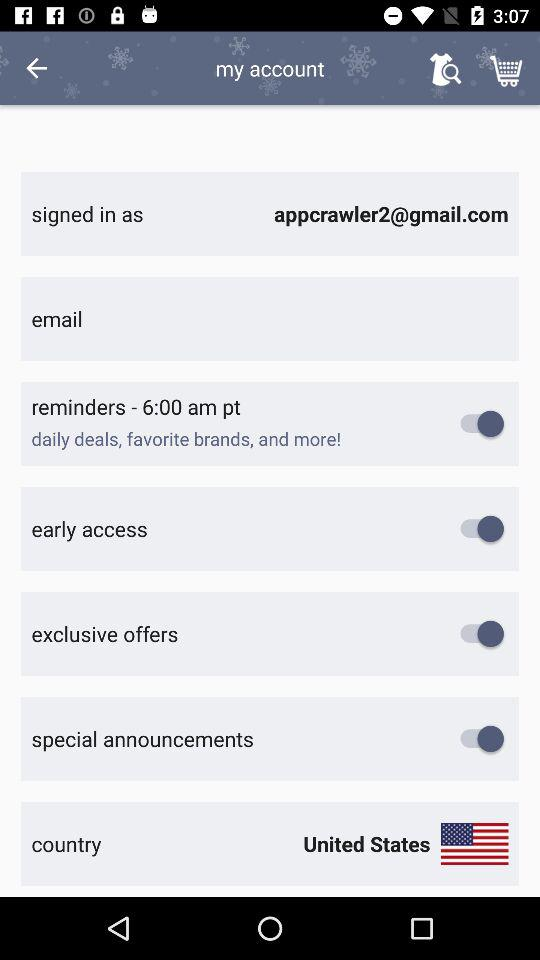What is the current status of the "special announcements"? The current status is "on". 